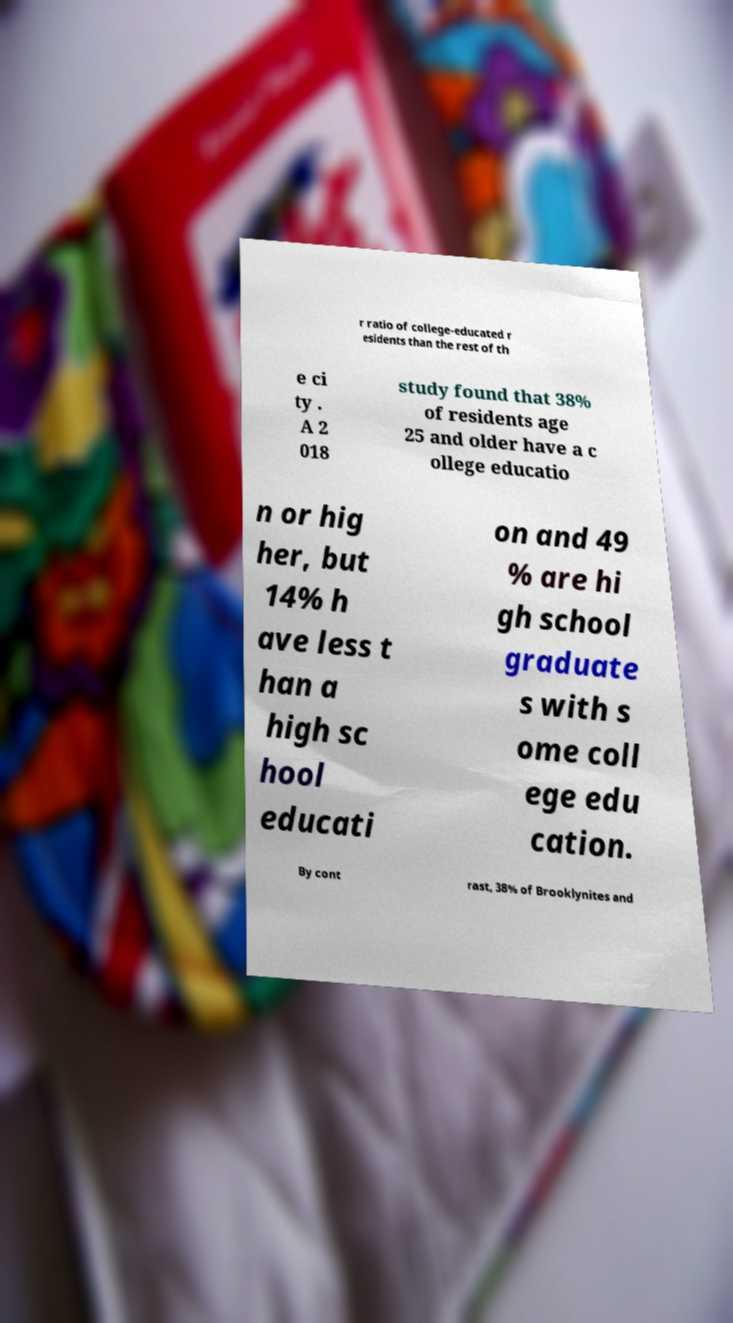Please read and relay the text visible in this image. What does it say? r ratio of college-educated r esidents than the rest of th e ci ty . A 2 018 study found that 38% of residents age 25 and older have a c ollege educatio n or hig her, but 14% h ave less t han a high sc hool educati on and 49 % are hi gh school graduate s with s ome coll ege edu cation. By cont rast, 38% of Brooklynites and 